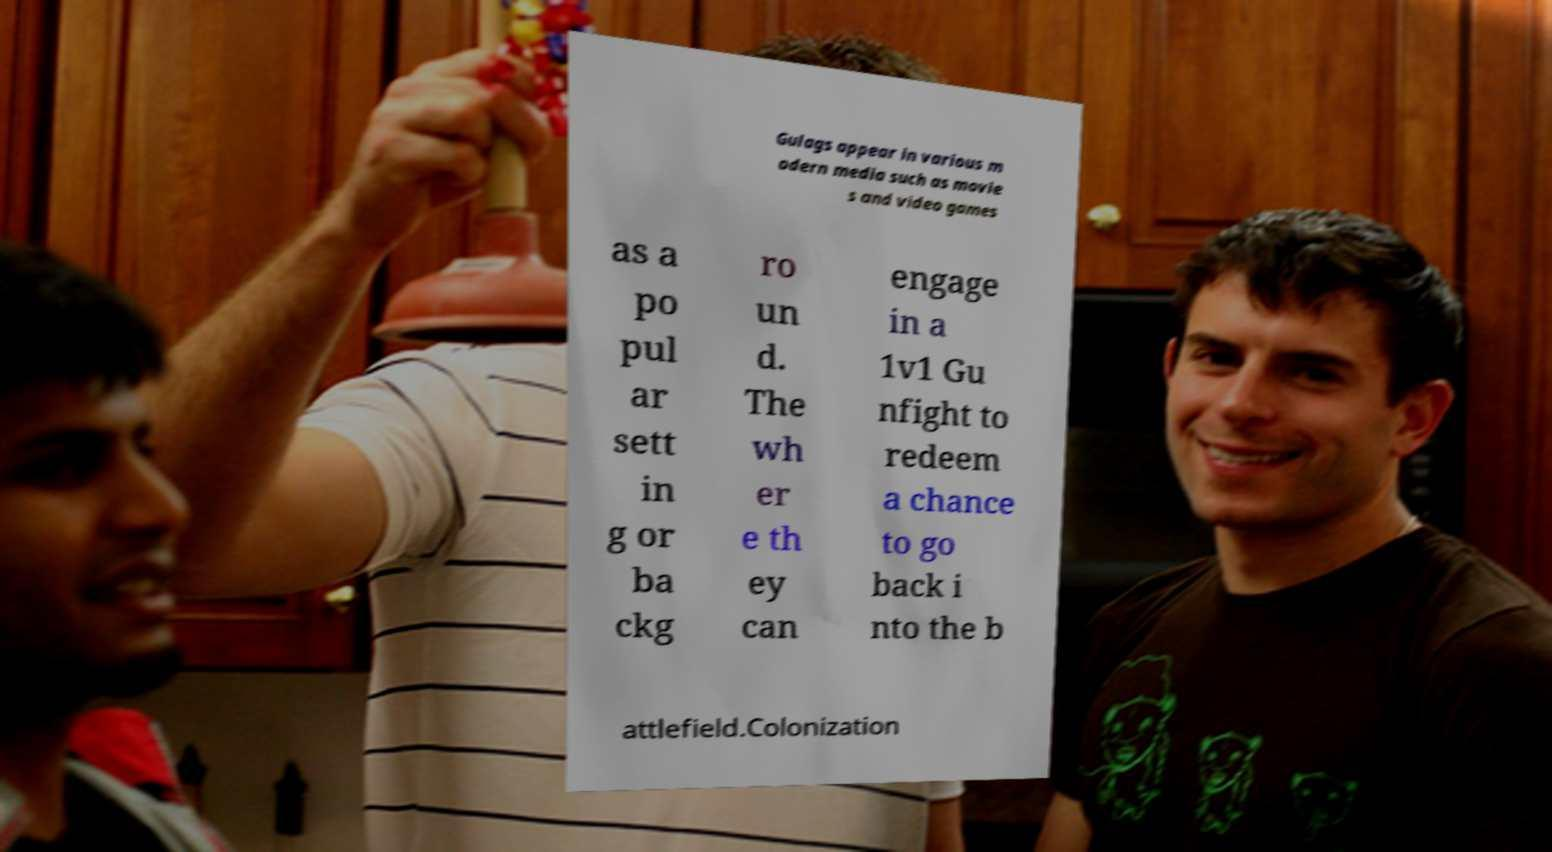I need the written content from this picture converted into text. Can you do that? Gulags appear in various m odern media such as movie s and video games as a po pul ar sett in g or ba ckg ro un d. The wh er e th ey can engage in a 1v1 Gu nfight to redeem a chance to go back i nto the b attlefield.Colonization 